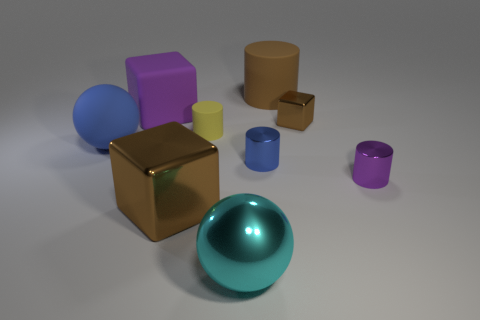Are there the same number of big matte cylinders that are right of the small brown object and tiny blue shiny objects on the left side of the blue sphere?
Offer a very short reply. Yes. What shape is the cyan metal object that is the same size as the rubber ball?
Ensure brevity in your answer.  Sphere. Are there any tiny matte cylinders of the same color as the large rubber cube?
Offer a very short reply. No. The big object that is to the left of the large purple cube has what shape?
Your response must be concise. Sphere. What is the color of the small metallic cube?
Provide a short and direct response. Brown. What is the color of the tiny cylinder that is the same material as the purple block?
Your answer should be compact. Yellow. How many large brown things have the same material as the cyan thing?
Give a very brief answer. 1. How many brown things are right of the brown matte cylinder?
Ensure brevity in your answer.  1. Do the big ball in front of the tiny purple thing and the purple thing left of the cyan metal sphere have the same material?
Your response must be concise. No. Is the number of large balls that are behind the large brown metallic block greater than the number of blue cylinders that are to the right of the brown matte cylinder?
Make the answer very short. Yes. 